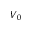<formula> <loc_0><loc_0><loc_500><loc_500>V _ { 0 }</formula> 